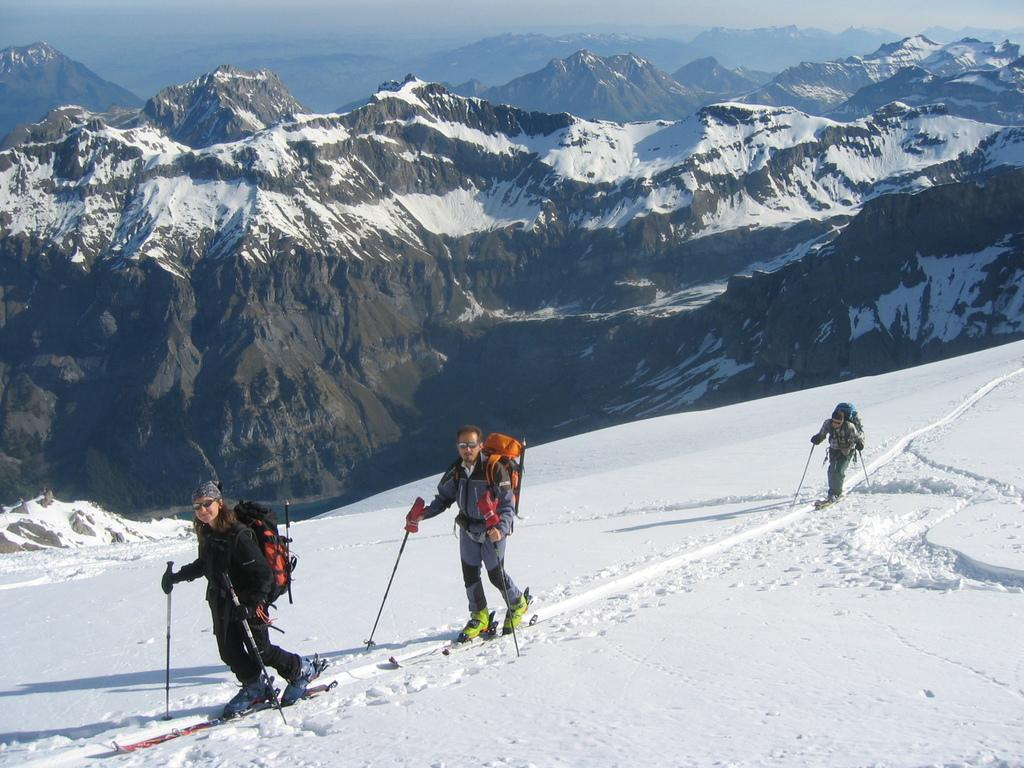How many people are in the image? There are three persons in the image. What are the persons doing in the image? The persons are skiing. What are the persons wearing on their backs? The persons are wearing bags. What type of footwear are the persons wearing? The persons are wearing ski-boards. What is the ground made of in the image? There is snow at the bottom of the image. What can be seen in the background of the image? There are mountains in the background of the image, and they are covered with snow. What is the tendency of the jellyfish in the image? There are no jellyfish present in the image. In which direction are the persons skiing in the image? The image does not provide information about the direction in which the persons are skiing. 